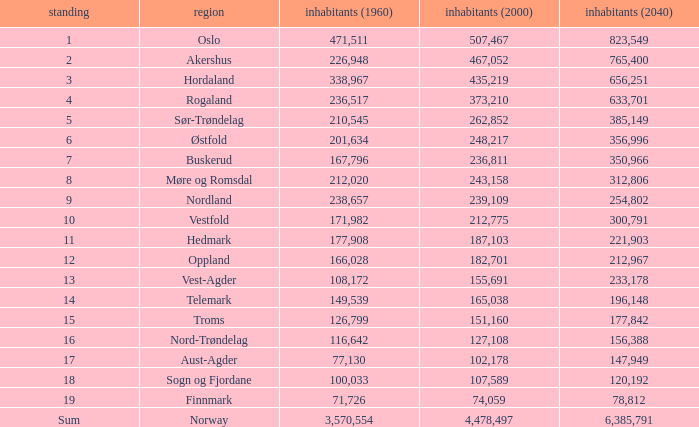What was the population of a county in 2040 that had a population less than 108,172 in 2000 and less than 107,589 in 1960? 2.0. 